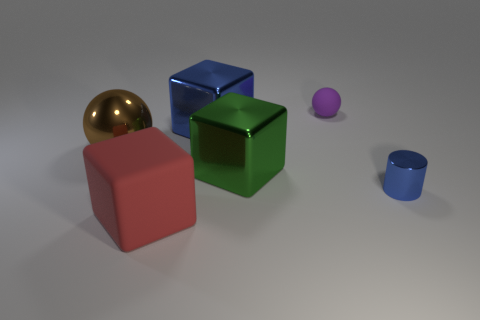Add 1 large red metallic cubes. How many objects exist? 7 Subtract all balls. How many objects are left? 4 Add 6 large red objects. How many large red objects exist? 7 Subtract 0 purple cylinders. How many objects are left? 6 Subtract all purple matte objects. Subtract all large blue objects. How many objects are left? 4 Add 6 large green shiny cubes. How many large green shiny cubes are left? 7 